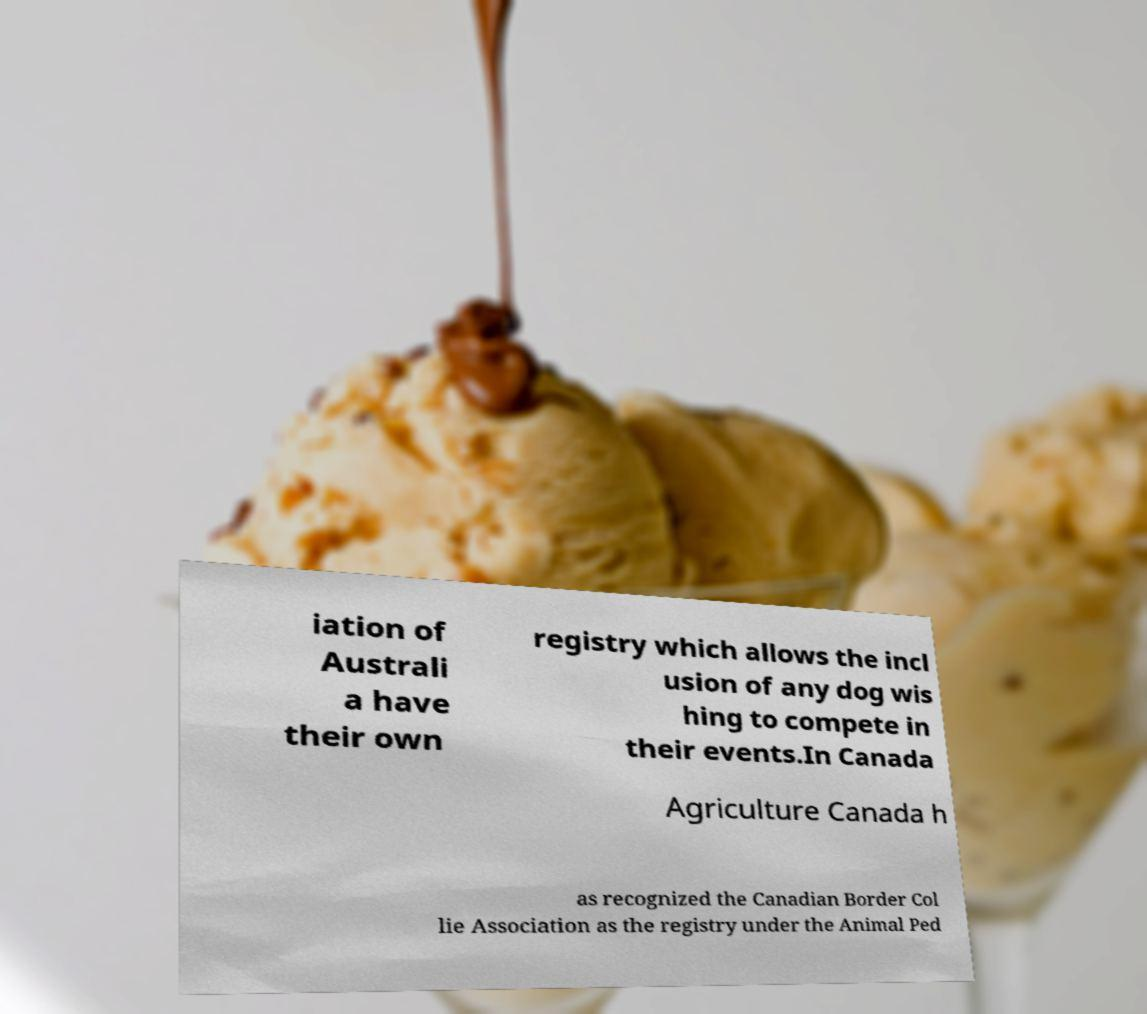Please read and relay the text visible in this image. What does it say? iation of Australi a have their own registry which allows the incl usion of any dog wis hing to compete in their events.In Canada Agriculture Canada h as recognized the Canadian Border Col lie Association as the registry under the Animal Ped 